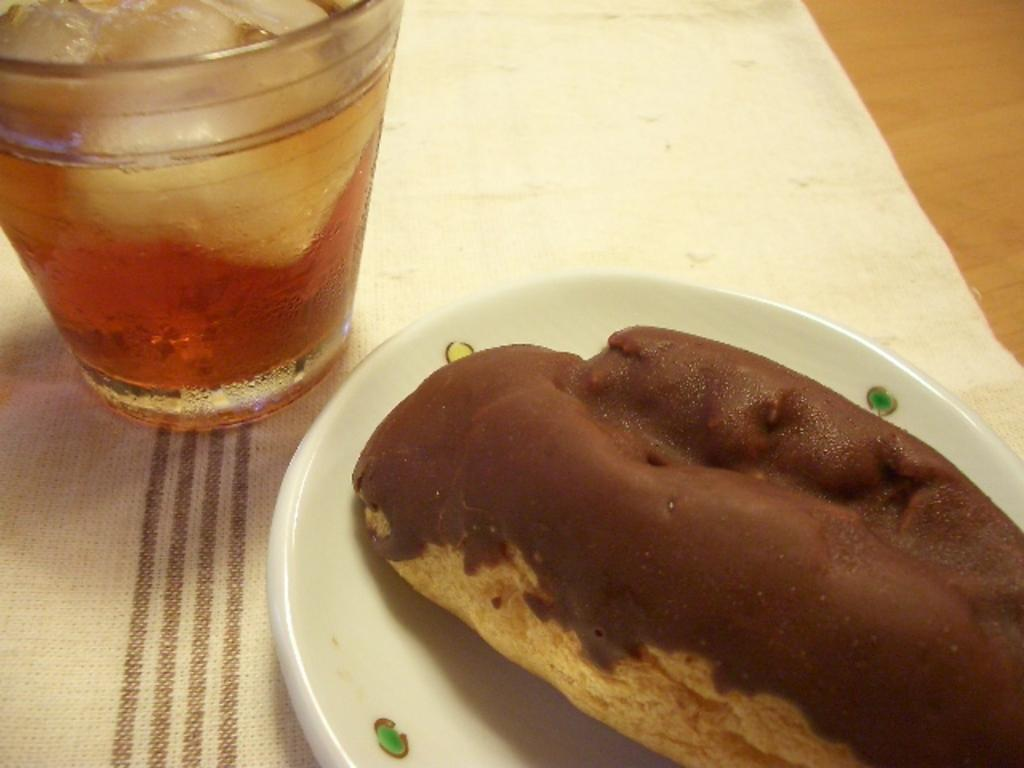What is inside the glass that is visible in the image? There is a glass with liquid and ice cubes in it. What can be seen on the plate in the image? There is a food item on a plate. What is covering the wooden object in the image? There is a cloth on a wooden object. What type of insect can be seen flying around the food item on the plate? There are no insects visible in the image; it only shows a glass with liquid and ice cubes, a food item on a plate, and a cloth on a wooden object. 